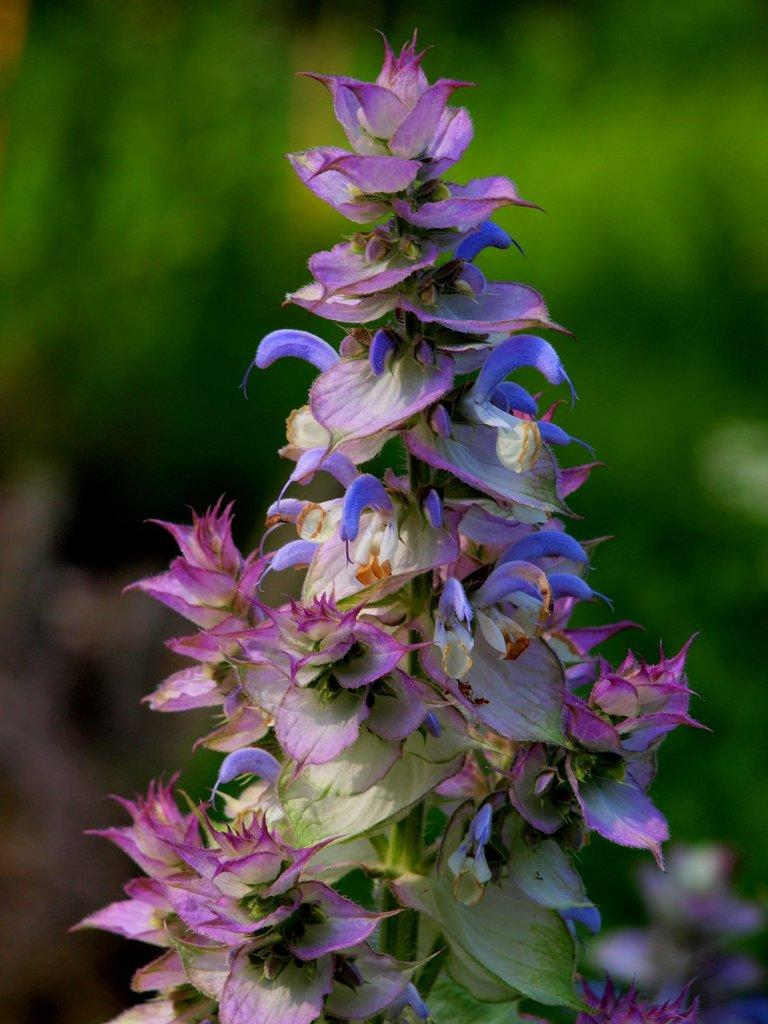What type of living organisms can be seen in the image? There are flowers in the image. How many different colors can be observed in the flowers? The flowers have different colors, including pink, violet, yellow, and white. What type of board is visible in the image? There is no board present in the image; it features flowers of different colors. What is the title of the book that can be seen in the image? There is no book or title present in the image; it features flowers of different colors. 